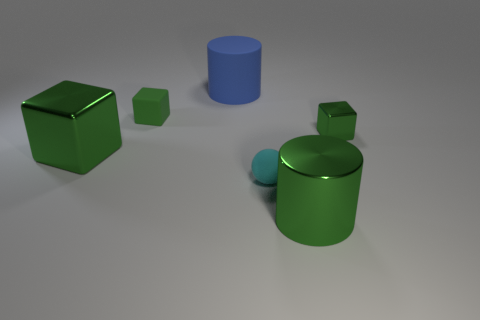How many green blocks must be subtracted to get 1 green blocks? 2 Add 3 small matte blocks. How many objects exist? 9 Subtract all spheres. How many objects are left? 5 Add 5 big green metallic things. How many big green metallic things exist? 7 Subtract 1 blue cylinders. How many objects are left? 5 Subtract all blue matte cylinders. Subtract all big green metallic objects. How many objects are left? 3 Add 1 green shiny cubes. How many green shiny cubes are left? 3 